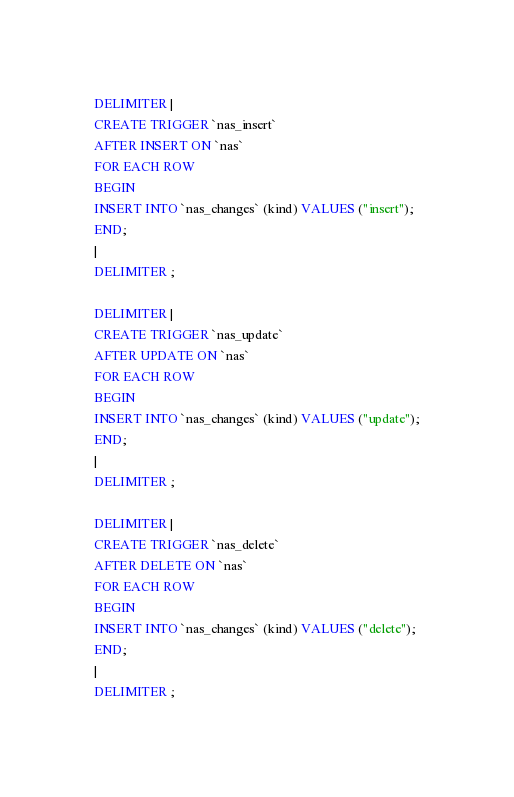Convert code to text. <code><loc_0><loc_0><loc_500><loc_500><_SQL_>DELIMITER |
CREATE TRIGGER `nas_insert`
AFTER INSERT ON `nas`
FOR EACH ROW
BEGIN
INSERT INTO `nas_changes` (kind) VALUES ("insert");
END;
|
DELIMITER ;

DELIMITER |
CREATE TRIGGER `nas_update`
AFTER UPDATE ON `nas`
FOR EACH ROW
BEGIN
INSERT INTO `nas_changes` (kind) VALUES ("update");
END;
|
DELIMITER ;

DELIMITER |
CREATE TRIGGER `nas_delete`
AFTER DELETE ON `nas`
FOR EACH ROW
BEGIN
INSERT INTO `nas_changes` (kind) VALUES ("delete");
END;
|
DELIMITER ;





</code> 